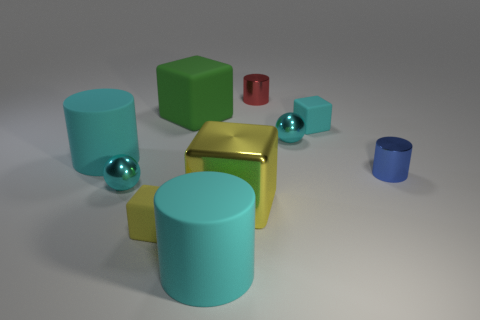Subtract all matte blocks. How many blocks are left? 1 Subtract all cyan cylinders. How many cylinders are left? 2 Subtract all cylinders. How many objects are left? 6 Subtract 1 spheres. How many spheres are left? 1 Add 10 large red blocks. How many large red blocks exist? 10 Subtract 1 cyan blocks. How many objects are left? 9 Subtract all blue blocks. Subtract all yellow spheres. How many blocks are left? 4 Subtract all cyan balls. How many blue cylinders are left? 1 Subtract all red metallic balls. Subtract all cyan objects. How many objects are left? 5 Add 7 small cyan matte things. How many small cyan matte things are left? 8 